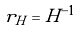Convert formula to latex. <formula><loc_0><loc_0><loc_500><loc_500>r _ { H } = H ^ { - 1 }</formula> 